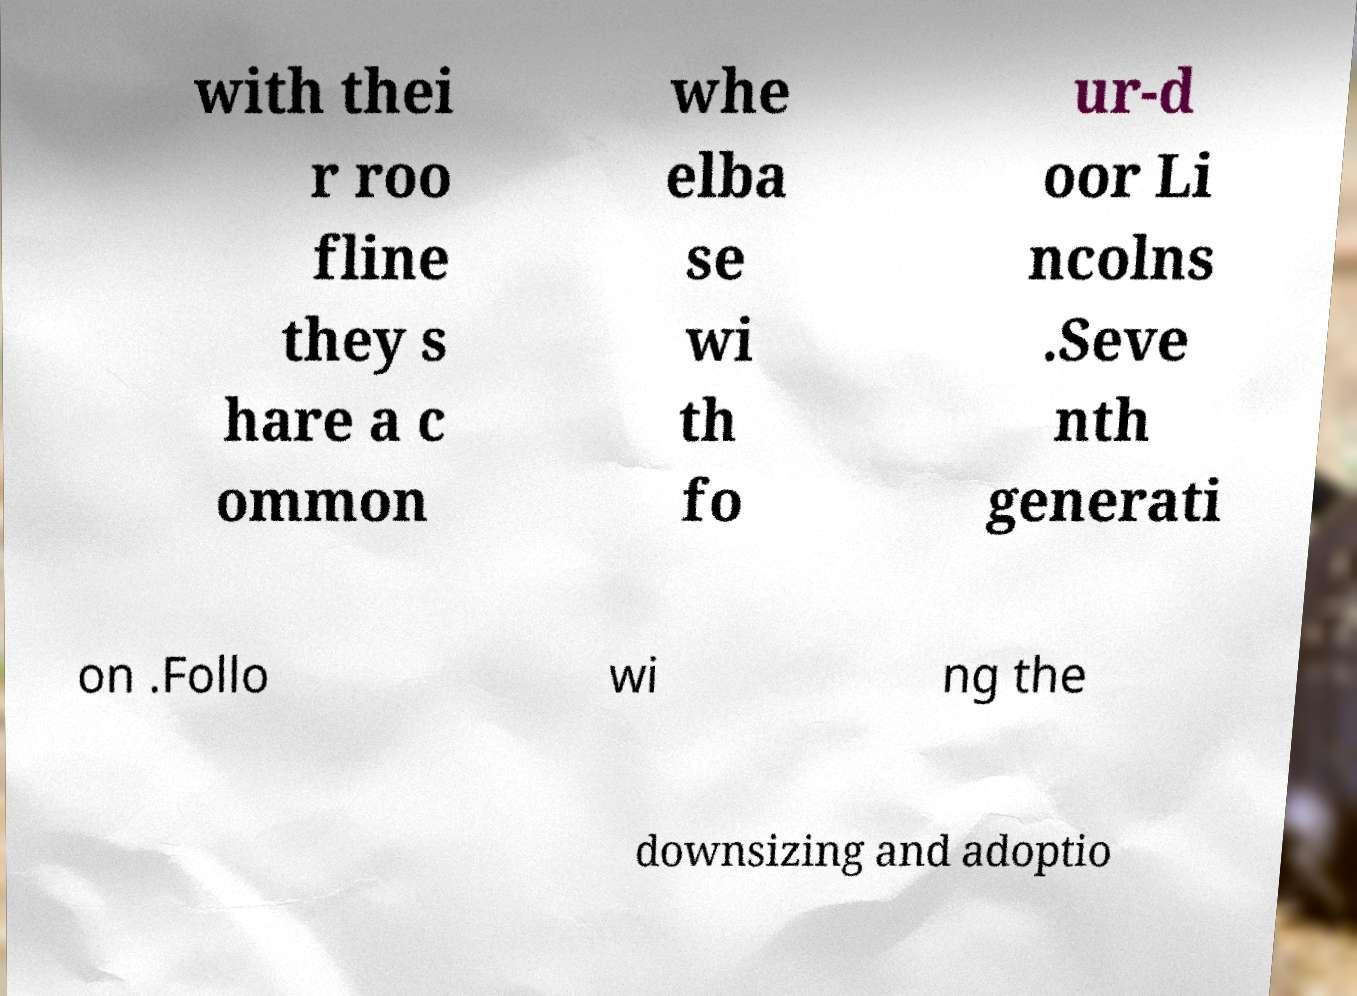Can you accurately transcribe the text from the provided image for me? with thei r roo fline they s hare a c ommon whe elba se wi th fo ur-d oor Li ncolns .Seve nth generati on .Follo wi ng the downsizing and adoptio 